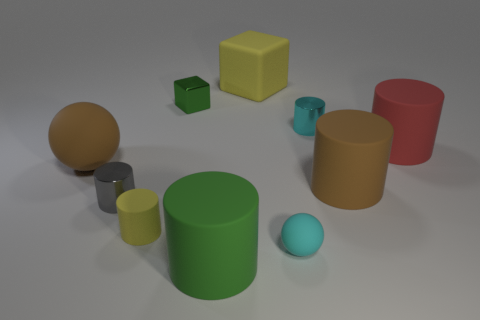Subtract 3 cylinders. How many cylinders are left? 3 Subtract all tiny rubber cylinders. How many cylinders are left? 5 Subtract all brown cylinders. How many cylinders are left? 5 Subtract all gray cylinders. Subtract all purple spheres. How many cylinders are left? 5 Subtract all blocks. How many objects are left? 8 Add 1 big yellow matte objects. How many big yellow matte objects are left? 2 Add 3 cyan cylinders. How many cyan cylinders exist? 4 Subtract 1 brown cylinders. How many objects are left? 9 Subtract all large red objects. Subtract all large gray cylinders. How many objects are left? 9 